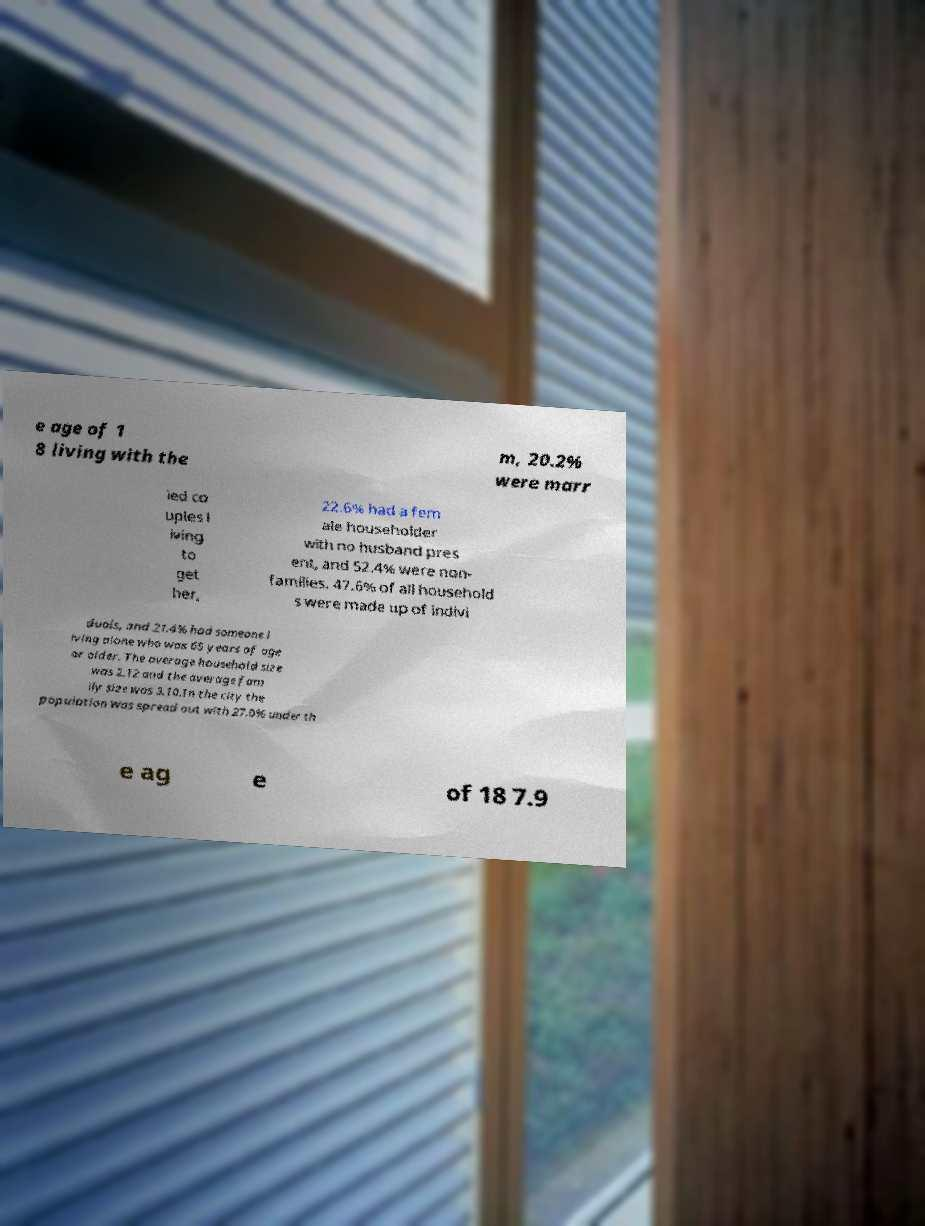There's text embedded in this image that I need extracted. Can you transcribe it verbatim? e age of 1 8 living with the m, 20.2% were marr ied co uples l iving to get her, 22.6% had a fem ale householder with no husband pres ent, and 52.4% were non- families. 47.6% of all household s were made up of indivi duals, and 21.4% had someone l iving alone who was 65 years of age or older. The average household size was 2.12 and the average fam ily size was 3.10.In the city the population was spread out with 27.0% under th e ag e of 18 7.9 